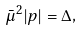<formula> <loc_0><loc_0><loc_500><loc_500>\bar { \mu } ^ { 2 } | p | = \Delta ,</formula> 